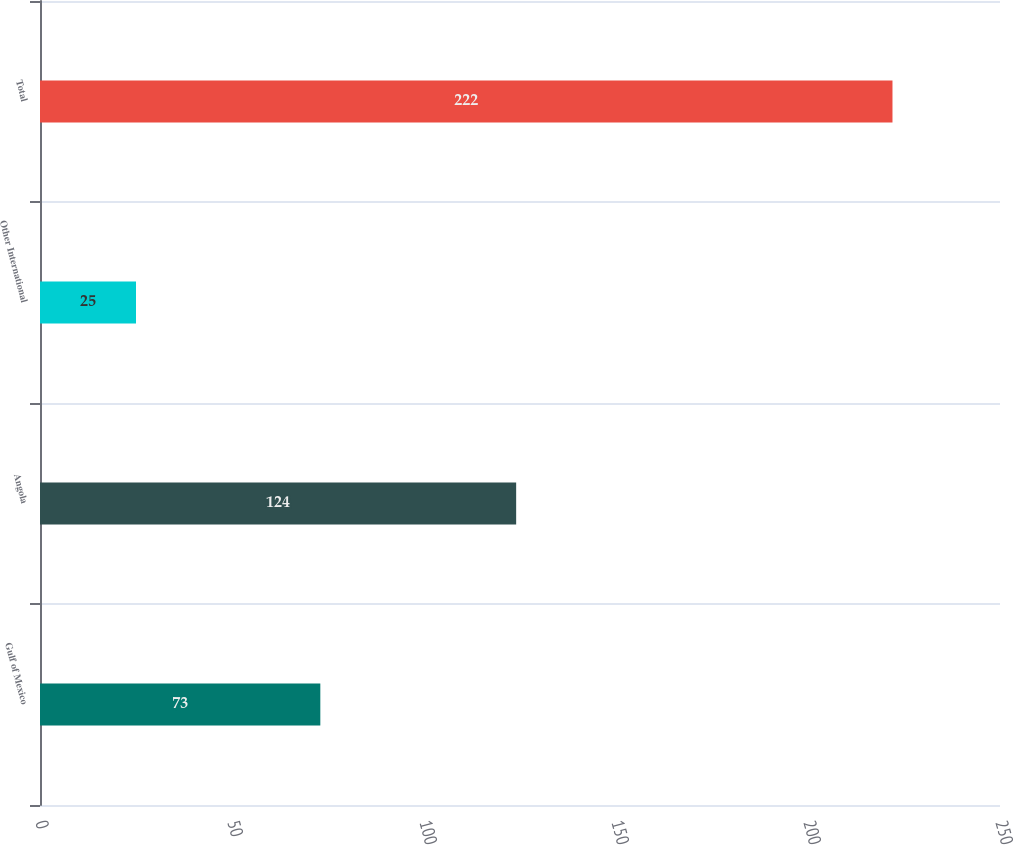Convert chart to OTSL. <chart><loc_0><loc_0><loc_500><loc_500><bar_chart><fcel>Gulf of Mexico<fcel>Angola<fcel>Other International<fcel>Total<nl><fcel>73<fcel>124<fcel>25<fcel>222<nl></chart> 